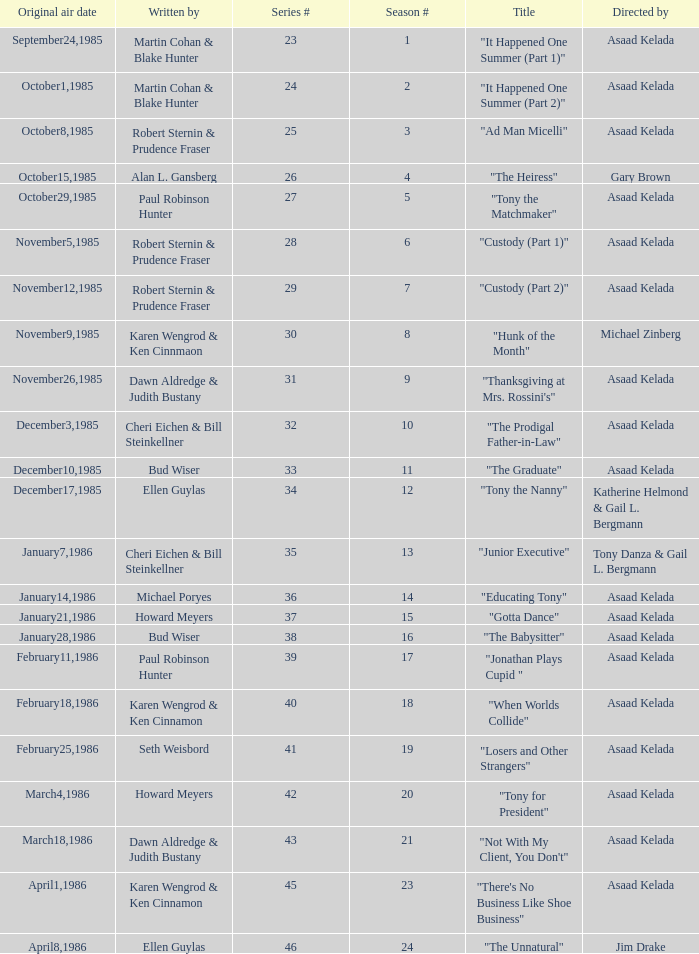Who were the authors of series episode #25? Robert Sternin & Prudence Fraser. 